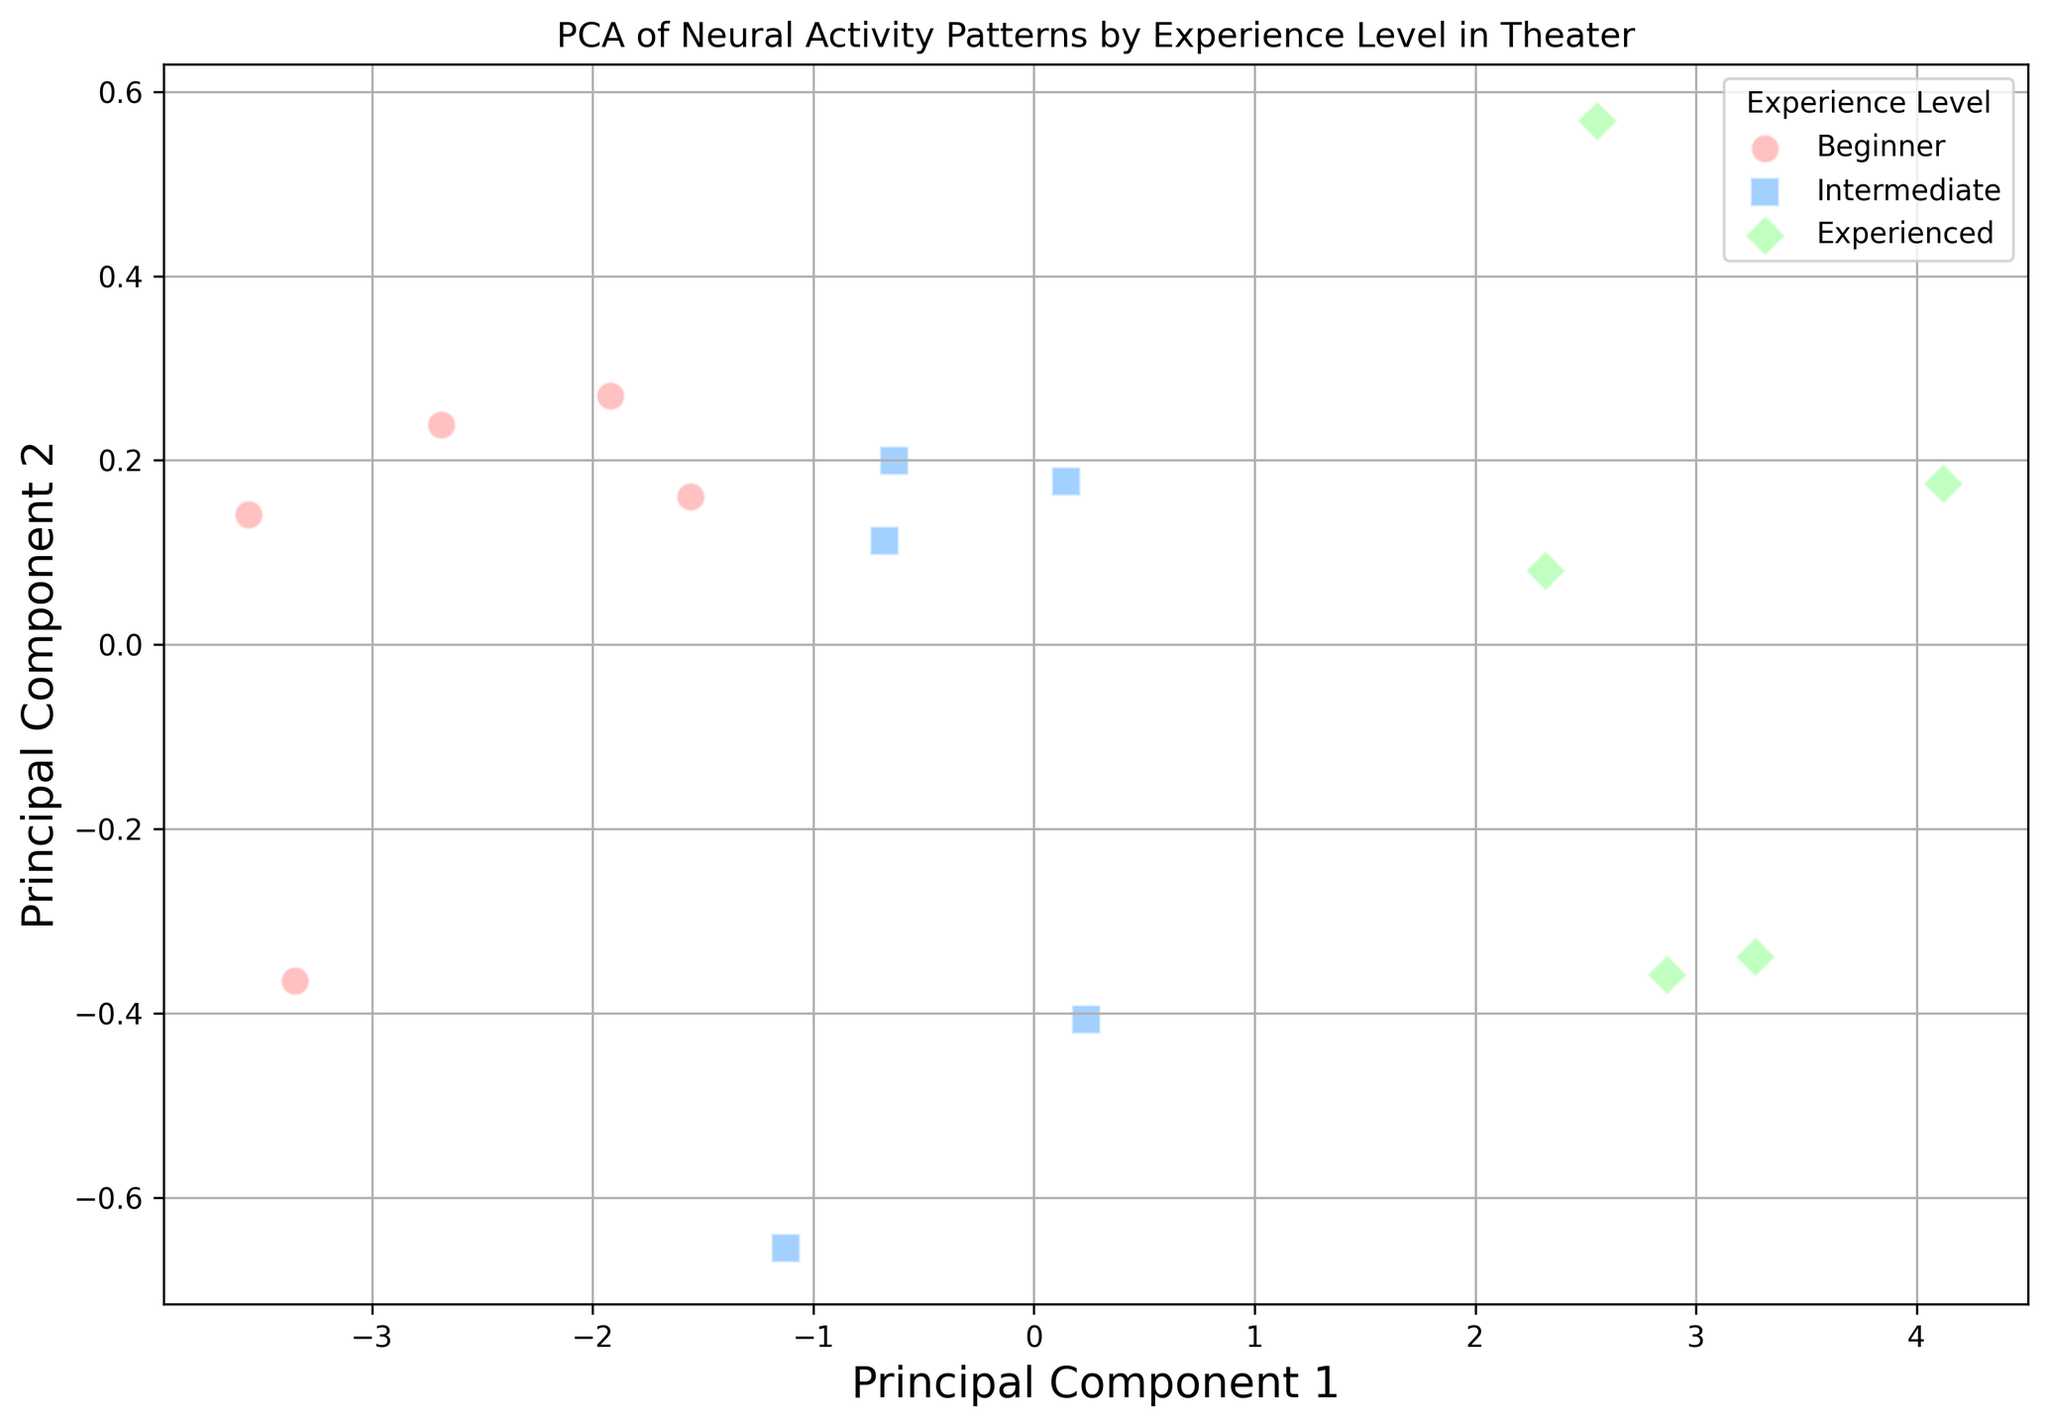What are the experience levels shown in the plot? The plot includes clusters labeled with different experience levels. By examining the labels in the legend, we can identify the distinct experience levels present in the plot.
Answer: Beginner, Intermediate, Experienced Which experience level has the highest principal component 1 values generally? By observing the spread of data points along the principal component 1 axis, we can see which experience level's points are placed more to the right. The experience level with the highest spread on the rightmost side generally has higher principal component 1 values.
Answer: Experienced What colors represent the different experience levels in the plot? By referring to the legend associated with the plot, we can identify the colors used to represent each experience level.
Answer: Beginner: red, Intermediate: blue, Experienced: green Are the clusters formed by the KMeans algorithm completely separated or do they overlap? We look for overlapping areas where data points from different clusters are close to or within the same vicinity.
Answer: They overlap How does the PCA dimensionality reduction improve the interpretability of neural activity patterns? PCA reduces the dimensionality of the data from six brain activity features to two principal components, making it easier to visualize and understand patterns across different experience levels through a 2D scatter plot.
Answer: It simplifies visualization Which cluster or clusters do experienced individuals primarily belong to? By examining the labels of the data points assigned to different clusters, we can determine which clusters are predominantly composed of experienced individuals.
Answer: A specific cluster distinguishable from other levels Is there a noticeable direction or trend in how neural activity patterns change with experience level in the PCA plot? By inspecting the arrangement of clusters along the principal component axes, we can infer any directional trend or gradient of neural activity changes with increasing experience level.
Answer: Increasing trend along principal component 1 What markers represent the different experience levels in the plot? The plot uses different shapes to indicate each experience level. By referring to the legend, we can determine the markers used for each level.
Answer: Beginner: circle, Intermediate: square, Experienced: diamond Are there more variations in principal component 1 or principal component 2? By observing the spread of data points along each principal component axis, we can compare the variation in both components. Wider dispersion indicates more variation.
Answer: Principal component 1 How well do the clusters separate the experience levels of individuals? By examining how distinctly the clusters are separated and whether each cluster is predominantly composed of individuals from a single experience level, we can judge the effectiveness of clustering.
Answer: Reasonably well but with some overlap 